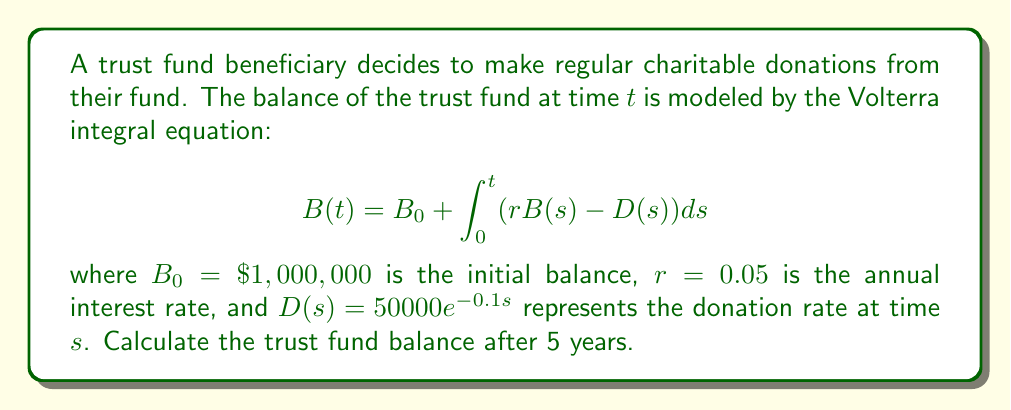Solve this math problem. To solve this Volterra integral equation, we'll use the following steps:

1) First, we differentiate both sides of the equation with respect to $t$:

   $$\frac{dB}{dt} = r B(t) - D(t)$$

2) This gives us a first-order linear differential equation. We can solve this using the integrating factor method.

3) The integrating factor is $e^{-rt}$. Multiplying both sides by this factor:

   $$e^{-rt}\frac{dB}{dt} - re^{-rt}B = -e^{-rt}D(t)$$

4) The left side is now the derivative of $e^{-rt}B$. So we can write:

   $$\frac{d}{dt}(e^{-rt}B) = -e^{-rt}D(t)$$

5) Integrating both sides from 0 to $t$:

   $$e^{-rt}B(t) - B_0 = -\int_0^t e^{-rs}D(s)ds$$

6) Substituting $D(s) = 50000e^{-0.1s}$:

   $$e^{-rt}B(t) - B_0 = -50000\int_0^t e^{-rs-0.1s}ds$$

7) Solving the integral:

   $$e^{-rt}B(t) - B_0 = -50000[\frac{-1}{r+0.1}e^{-(r+0.1)s}]_0^t$$

8) Evaluating the limits:

   $$e^{-rt}B(t) - B_0 = -50000(\frac{-1}{r+0.1}e^{-(r+0.1)t} + \frac{1}{r+0.1})$$

9) Solving for $B(t)$:

   $$B(t) = B_0e^{rt} + 50000(\frac{1-e^{-(r+0.1)t}}{r+0.1})e^{rt}$$

10) Now we can substitute the values: $B_0 = 1000000$, $r = 0.05$, $t = 5$:

    $$B(5) = 1000000e^{0.05*5} + 50000(\frac{1-e^{-(0.05+0.1)*5}}{0.05+0.1})e^{0.05*5}$$

11) Calculating this gives us:

    $$B(5) \approx 1,223,199.22$$
Answer: $1,223,199.22 